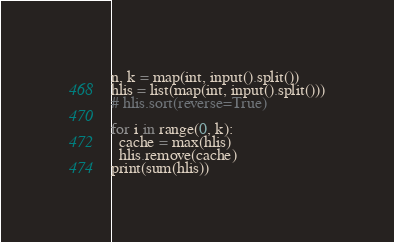<code> <loc_0><loc_0><loc_500><loc_500><_Python_>n, k = map(int, input().split())
hlis = list(map(int, input().split()))
# hlis.sort(reverse=True)

for i in range(0, k):
  cache = max(hlis)
  hlis.remove(cache)
print(sum(hlis))</code> 